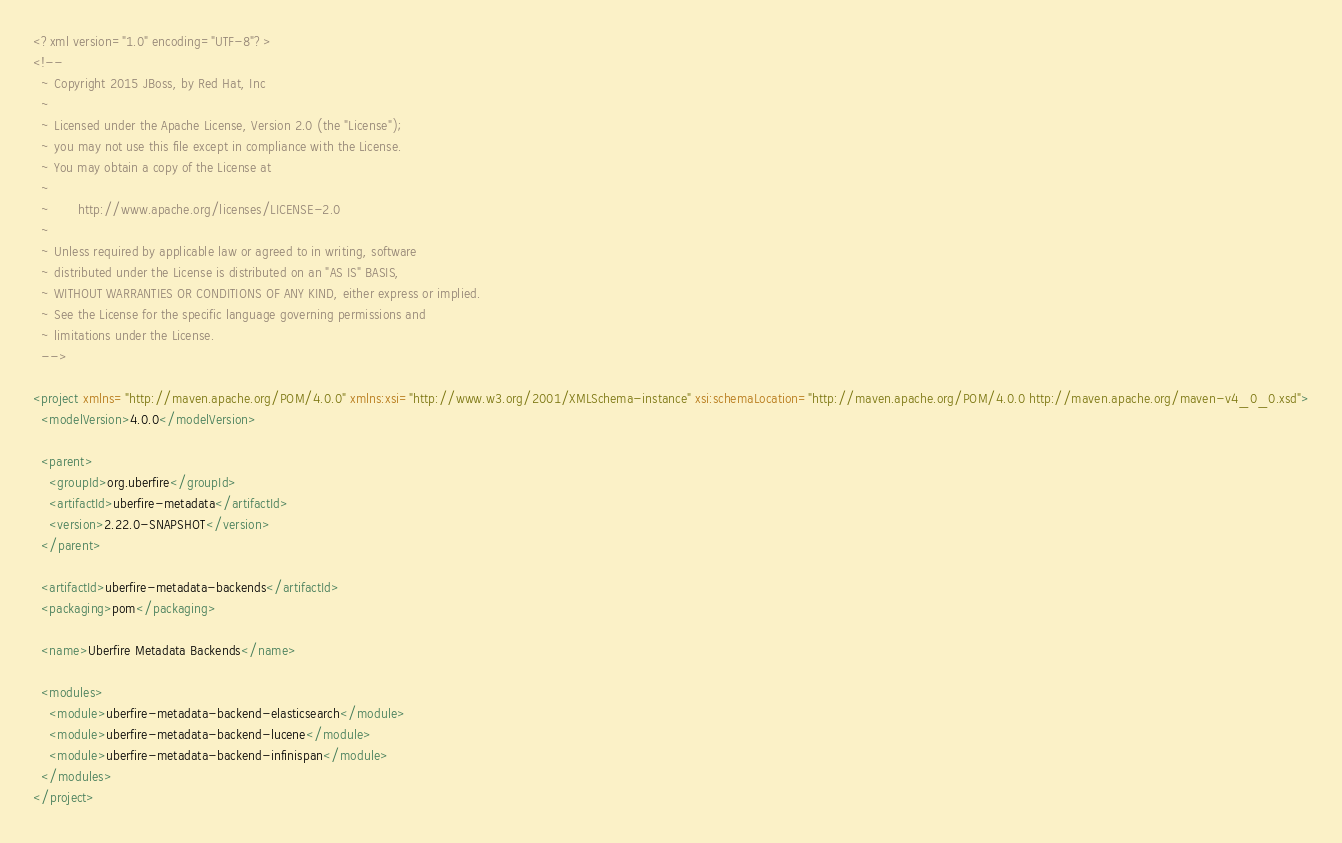Convert code to text. <code><loc_0><loc_0><loc_500><loc_500><_XML_><?xml version="1.0" encoding="UTF-8"?>
<!--
  ~ Copyright 2015 JBoss, by Red Hat, Inc
  ~
  ~ Licensed under the Apache License, Version 2.0 (the "License");
  ~ you may not use this file except in compliance with the License.
  ~ You may obtain a copy of the License at
  ~
  ~       http://www.apache.org/licenses/LICENSE-2.0
  ~
  ~ Unless required by applicable law or agreed to in writing, software
  ~ distributed under the License is distributed on an "AS IS" BASIS,
  ~ WITHOUT WARRANTIES OR CONDITIONS OF ANY KIND, either express or implied.
  ~ See the License for the specific language governing permissions and
  ~ limitations under the License.
  -->

<project xmlns="http://maven.apache.org/POM/4.0.0" xmlns:xsi="http://www.w3.org/2001/XMLSchema-instance" xsi:schemaLocation="http://maven.apache.org/POM/4.0.0 http://maven.apache.org/maven-v4_0_0.xsd">
  <modelVersion>4.0.0</modelVersion>

  <parent>
    <groupId>org.uberfire</groupId>
    <artifactId>uberfire-metadata</artifactId>
    <version>2.22.0-SNAPSHOT</version>
  </parent>

  <artifactId>uberfire-metadata-backends</artifactId>
  <packaging>pom</packaging>

  <name>Uberfire Metadata Backends</name>

  <modules>
    <module>uberfire-metadata-backend-elasticsearch</module>
    <module>uberfire-metadata-backend-lucene</module>
    <module>uberfire-metadata-backend-infinispan</module>
  </modules>
</project>
</code> 